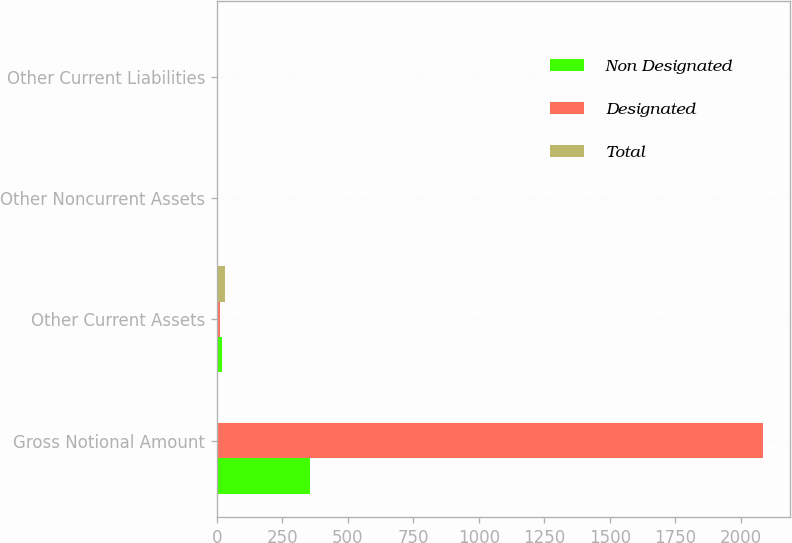<chart> <loc_0><loc_0><loc_500><loc_500><stacked_bar_chart><ecel><fcel>Gross Notional Amount<fcel>Other Current Assets<fcel>Other Noncurrent Assets<fcel>Other Current Liabilities<nl><fcel>Non Designated<fcel>357<fcel>18<fcel>1<fcel>1<nl><fcel>Designated<fcel>2085<fcel>12<fcel>3<fcel>1<nl><fcel>Total<fcel>4<fcel>30<fcel>4<fcel>2<nl></chart> 